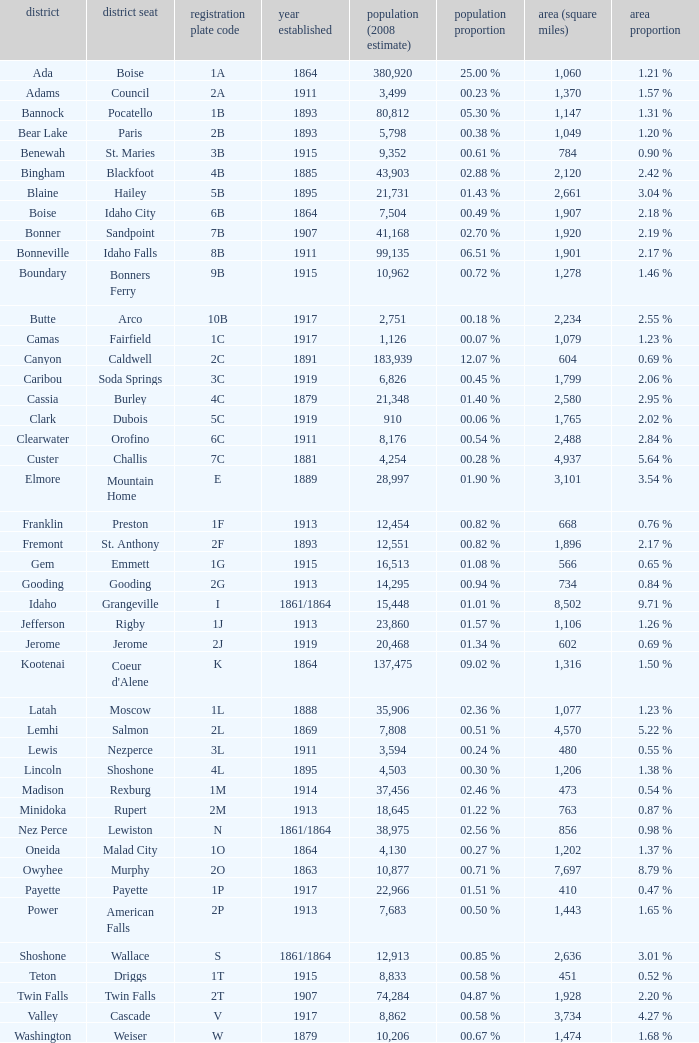What is the license plate code for the country with an area of 784? 3B. 